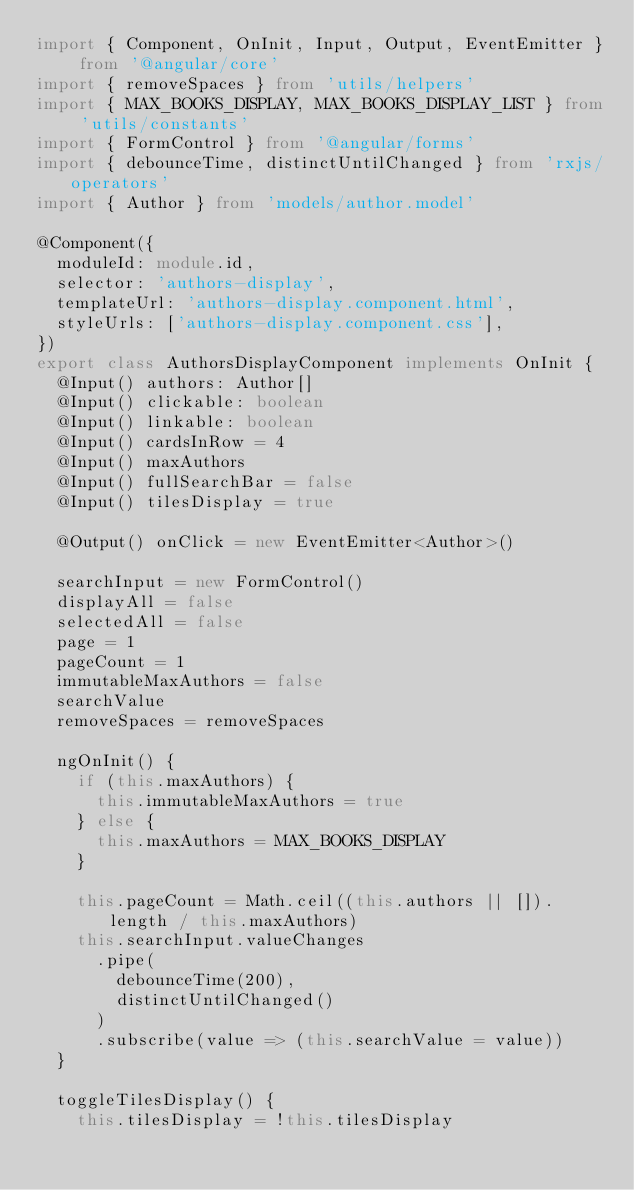Convert code to text. <code><loc_0><loc_0><loc_500><loc_500><_TypeScript_>import { Component, OnInit, Input, Output, EventEmitter } from '@angular/core'
import { removeSpaces } from 'utils/helpers'
import { MAX_BOOKS_DISPLAY, MAX_BOOKS_DISPLAY_LIST } from 'utils/constants'
import { FormControl } from '@angular/forms'
import { debounceTime, distinctUntilChanged } from 'rxjs/operators'
import { Author } from 'models/author.model'

@Component({
  moduleId: module.id,
  selector: 'authors-display',
  templateUrl: 'authors-display.component.html',
  styleUrls: ['authors-display.component.css'],
})
export class AuthorsDisplayComponent implements OnInit {
  @Input() authors: Author[]
  @Input() clickable: boolean
  @Input() linkable: boolean
  @Input() cardsInRow = 4
  @Input() maxAuthors
  @Input() fullSearchBar = false
  @Input() tilesDisplay = true

  @Output() onClick = new EventEmitter<Author>()

  searchInput = new FormControl()
  displayAll = false
  selectedAll = false
  page = 1
  pageCount = 1
  immutableMaxAuthors = false
  searchValue
  removeSpaces = removeSpaces

  ngOnInit() {
    if (this.maxAuthors) {
      this.immutableMaxAuthors = true
    } else {
      this.maxAuthors = MAX_BOOKS_DISPLAY
    }

    this.pageCount = Math.ceil((this.authors || []).length / this.maxAuthors)
    this.searchInput.valueChanges
      .pipe(
        debounceTime(200),
        distinctUntilChanged()
      )
      .subscribe(value => (this.searchValue = value))
  }

  toggleTilesDisplay() {
    this.tilesDisplay = !this.tilesDisplay</code> 